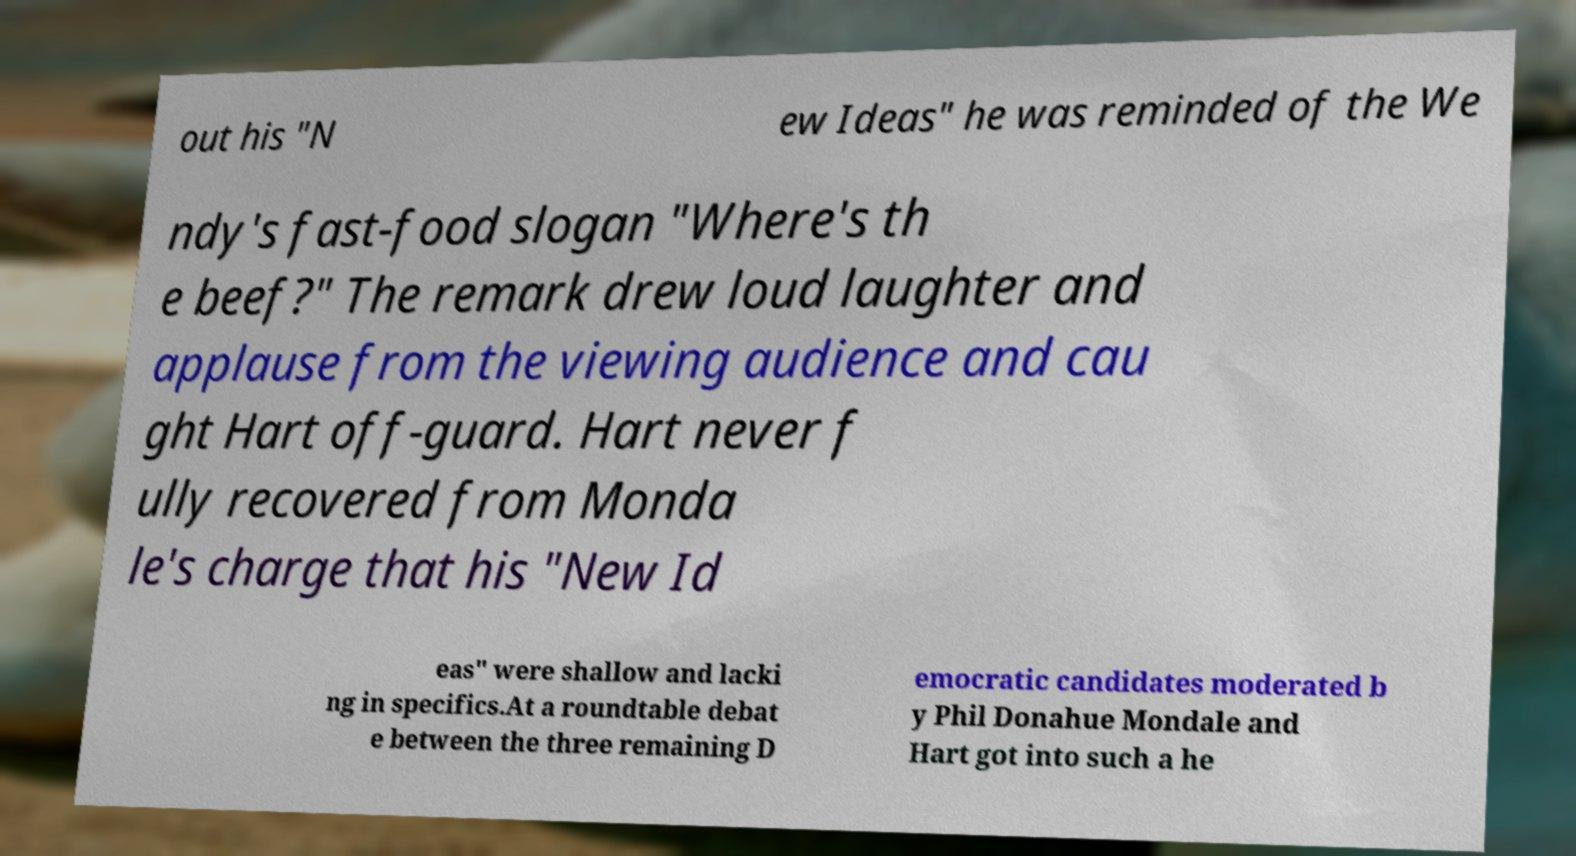Can you accurately transcribe the text from the provided image for me? out his "N ew Ideas" he was reminded of the We ndy's fast-food slogan "Where's th e beef?" The remark drew loud laughter and applause from the viewing audience and cau ght Hart off-guard. Hart never f ully recovered from Monda le's charge that his "New Id eas" were shallow and lacki ng in specifics.At a roundtable debat e between the three remaining D emocratic candidates moderated b y Phil Donahue Mondale and Hart got into such a he 